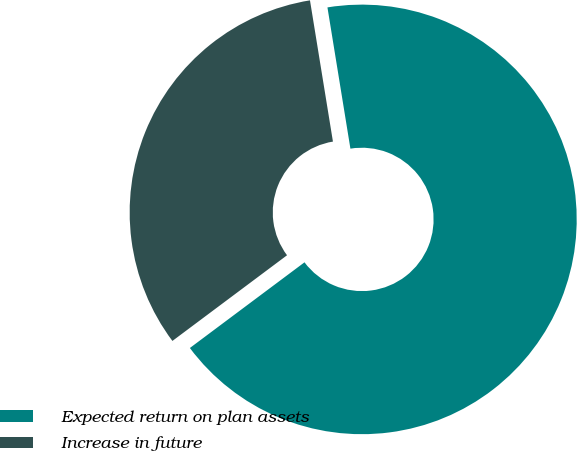<chart> <loc_0><loc_0><loc_500><loc_500><pie_chart><fcel>Expected return on plan assets<fcel>Increase in future<nl><fcel>67.35%<fcel>32.65%<nl></chart> 